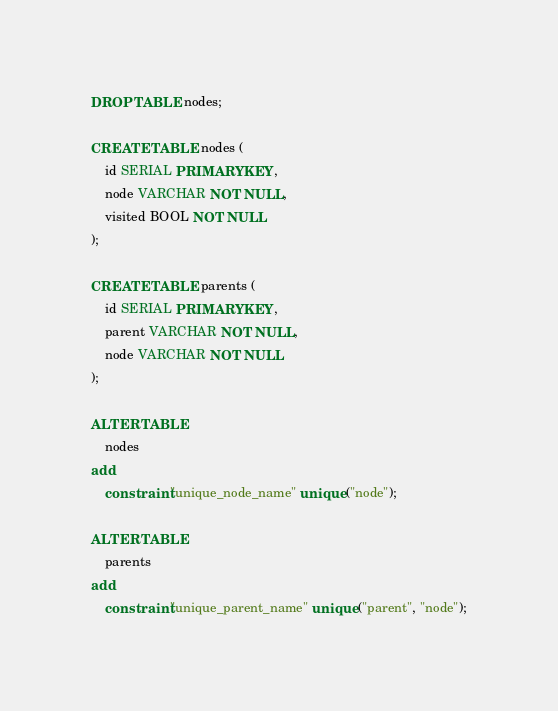<code> <loc_0><loc_0><loc_500><loc_500><_SQL_>DROP TABLE nodes;

CREATE TABLE nodes (
    id SERIAL PRIMARY KEY,
    node VARCHAR NOT NULL,
    visited BOOL NOT NULL
);

CREATE TABLE parents (
    id SERIAL PRIMARY KEY,
    parent VARCHAR NOT NULL,
    node VARCHAR NOT NULL
);

ALTER TABLE
    nodes
add
    constraint "unique_node_name" unique ("node");

ALTER TABLE
    parents
add
    constraint "unique_parent_name" unique ("parent", "node");</code> 